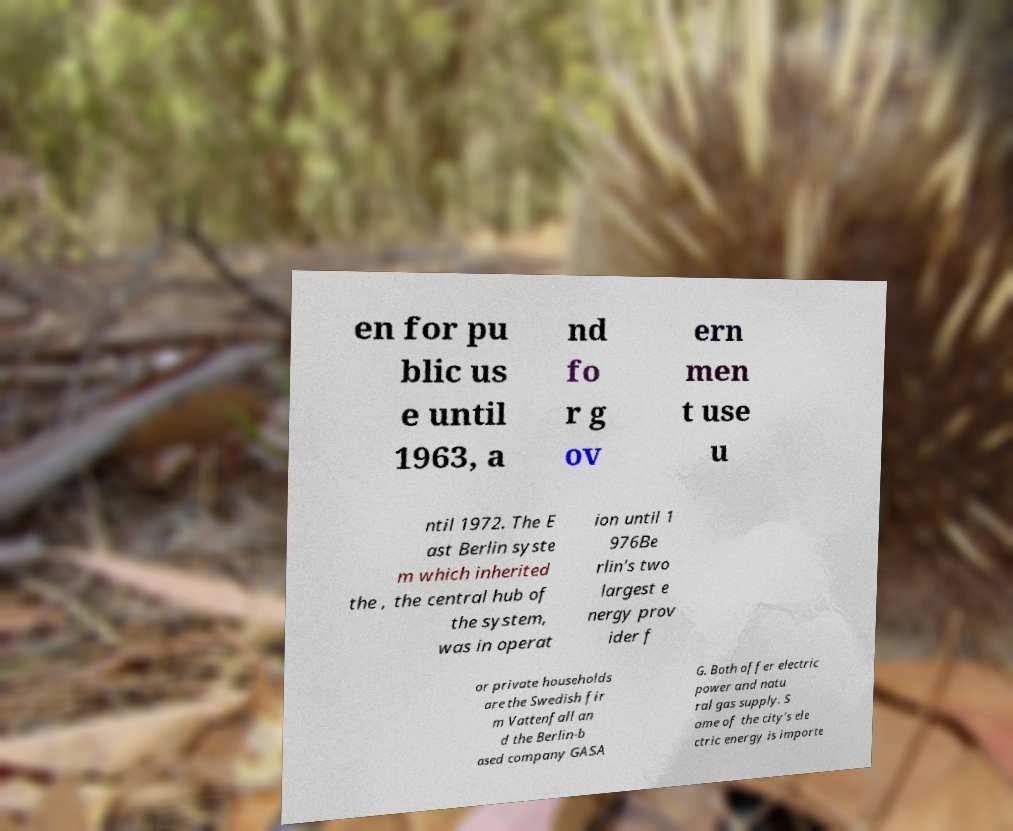Can you read and provide the text displayed in the image?This photo seems to have some interesting text. Can you extract and type it out for me? en for pu blic us e until 1963, a nd fo r g ov ern men t use u ntil 1972. The E ast Berlin syste m which inherited the , the central hub of the system, was in operat ion until 1 976Be rlin's two largest e nergy prov ider f or private households are the Swedish fir m Vattenfall an d the Berlin-b ased company GASA G. Both offer electric power and natu ral gas supply. S ome of the city's ele ctric energy is importe 